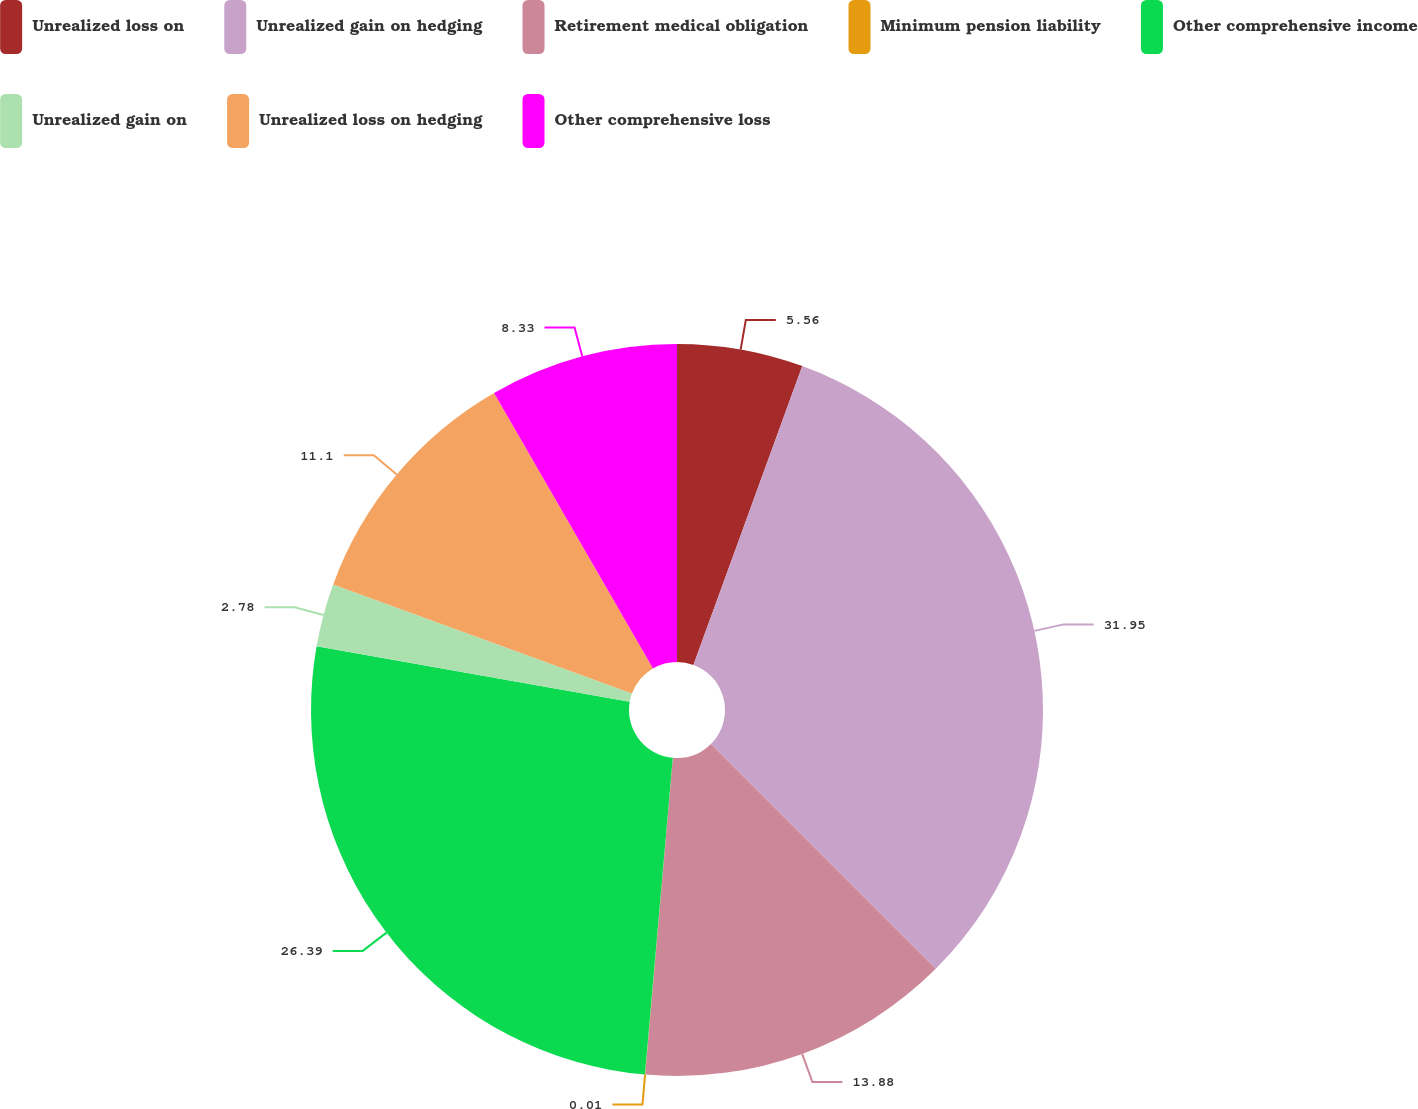<chart> <loc_0><loc_0><loc_500><loc_500><pie_chart><fcel>Unrealized loss on<fcel>Unrealized gain on hedging<fcel>Retirement medical obligation<fcel>Minimum pension liability<fcel>Other comprehensive income<fcel>Unrealized gain on<fcel>Unrealized loss on hedging<fcel>Other comprehensive loss<nl><fcel>5.56%<fcel>31.94%<fcel>13.88%<fcel>0.01%<fcel>26.39%<fcel>2.78%<fcel>11.1%<fcel>8.33%<nl></chart> 